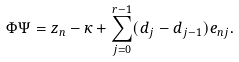<formula> <loc_0><loc_0><loc_500><loc_500>\Phi \Psi = z _ { n } - \kappa + \sum _ { j = 0 } ^ { r - 1 } ( d _ { j } - d _ { j - 1 } ) e _ { n j } .</formula> 